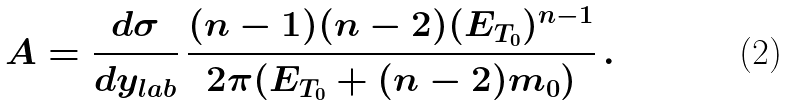<formula> <loc_0><loc_0><loc_500><loc_500>A = \frac { d \sigma } { d y _ { l a b } } \, \frac { ( n - 1 ) ( n - 2 ) ( E _ { T _ { 0 } } ) ^ { n - 1 } } { 2 \pi ( E _ { T _ { 0 } } + ( n - 2 ) m _ { 0 } ) } \, .</formula> 